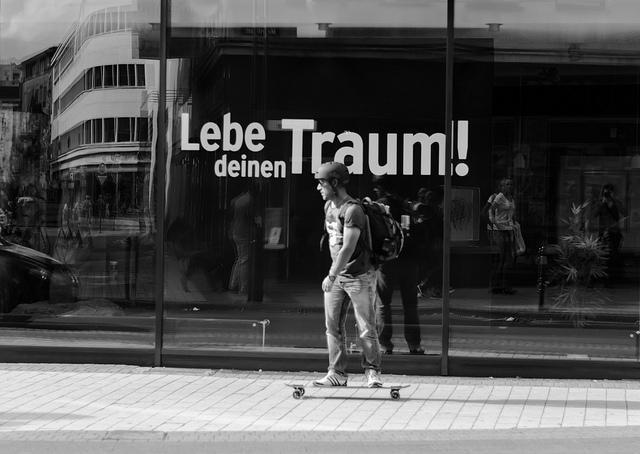How many people can be seen?
Give a very brief answer. 4. 